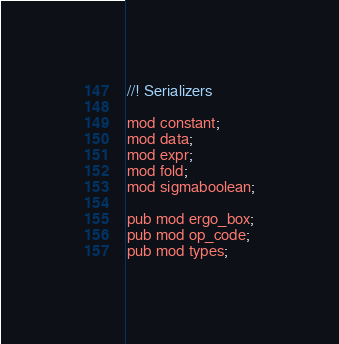Convert code to text. <code><loc_0><loc_0><loc_500><loc_500><_Rust_>//! Serializers

mod constant;
mod data;
mod expr;
mod fold;
mod sigmaboolean;

pub mod ergo_box;
pub mod op_code;
pub mod types;
</code> 